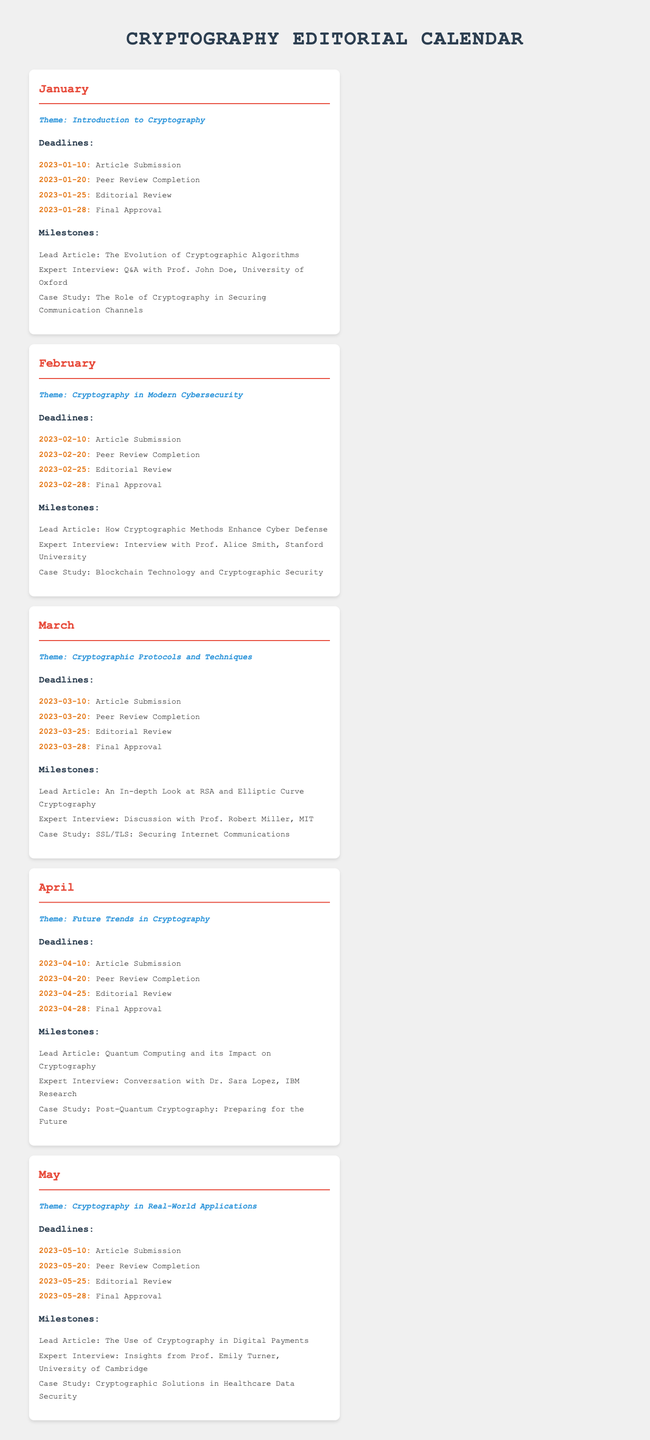What is the theme for January? The theme for January is specified in the calendar and it is "Introduction to Cryptography".
Answer: Introduction to Cryptography What is the final approval date for June? The final approval date for June is not available in the document as it only lists up to May.
Answer: N/A Who is the lead article for February? The lead article for February is listed in the document, which is "How Cryptographic Methods Enhance Cyber Defense".
Answer: How Cryptographic Methods Enhance Cyber Defense When is the article submission deadline for April? The document specifies the article submission deadline for April as 2023-04-10.
Answer: 2023-04-10 Which expert was interviewed in March? The document lists that March features an interview with "Prof. Robert Miller, MIT".
Answer: Prof. Robert Miller, MIT What is the theme for May? The theme for May is provided in the document as "Cryptography in Real-World Applications".
Answer: Cryptography in Real-World Applications What case study is highlighted in April? The case study for April is mentioned as "Post-Quantum Cryptography: Preparing for the Future".
Answer: Post-Quantum Cryptography: Preparing for the Future How many milestones are listed for January? The document provides three milestones listed under January.
Answer: 3 What is the peer review completion date for March? The peer review completion date specified for March is 2023-03-20.
Answer: 2023-03-20 